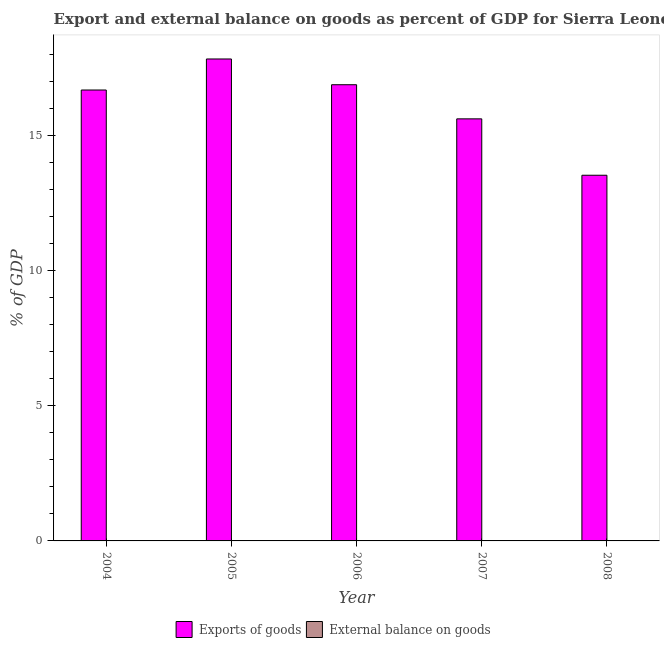How many different coloured bars are there?
Your response must be concise. 1. How many bars are there on the 5th tick from the left?
Make the answer very short. 1. How many bars are there on the 5th tick from the right?
Offer a very short reply. 1. What is the label of the 4th group of bars from the left?
Keep it short and to the point. 2007. Across all years, what is the maximum export of goods as percentage of gdp?
Your answer should be compact. 17.82. Across all years, what is the minimum export of goods as percentage of gdp?
Make the answer very short. 13.52. In which year was the export of goods as percentage of gdp maximum?
Make the answer very short. 2005. What is the total external balance on goods as percentage of gdp in the graph?
Your answer should be very brief. 0. What is the difference between the export of goods as percentage of gdp in 2005 and that in 2008?
Provide a short and direct response. 4.3. What is the average export of goods as percentage of gdp per year?
Offer a very short reply. 16.1. What is the ratio of the export of goods as percentage of gdp in 2004 to that in 2008?
Ensure brevity in your answer.  1.23. Is the difference between the export of goods as percentage of gdp in 2004 and 2008 greater than the difference between the external balance on goods as percentage of gdp in 2004 and 2008?
Your answer should be very brief. No. What is the difference between the highest and the second highest export of goods as percentage of gdp?
Your answer should be very brief. 0.95. What is the difference between the highest and the lowest export of goods as percentage of gdp?
Offer a very short reply. 4.3. Is the sum of the export of goods as percentage of gdp in 2004 and 2008 greater than the maximum external balance on goods as percentage of gdp across all years?
Give a very brief answer. Yes. How many years are there in the graph?
Your answer should be compact. 5. What is the difference between two consecutive major ticks on the Y-axis?
Give a very brief answer. 5. Are the values on the major ticks of Y-axis written in scientific E-notation?
Provide a short and direct response. No. Where does the legend appear in the graph?
Ensure brevity in your answer.  Bottom center. How many legend labels are there?
Keep it short and to the point. 2. How are the legend labels stacked?
Your answer should be compact. Horizontal. What is the title of the graph?
Your answer should be compact. Export and external balance on goods as percent of GDP for Sierra Leone. What is the label or title of the Y-axis?
Provide a succinct answer. % of GDP. What is the % of GDP in Exports of goods in 2004?
Offer a terse response. 16.67. What is the % of GDP of Exports of goods in 2005?
Ensure brevity in your answer.  17.82. What is the % of GDP in External balance on goods in 2005?
Provide a short and direct response. 0. What is the % of GDP in Exports of goods in 2006?
Offer a terse response. 16.87. What is the % of GDP in External balance on goods in 2006?
Make the answer very short. 0. What is the % of GDP of Exports of goods in 2007?
Provide a succinct answer. 15.6. What is the % of GDP in Exports of goods in 2008?
Offer a terse response. 13.52. Across all years, what is the maximum % of GDP of Exports of goods?
Offer a very short reply. 17.82. Across all years, what is the minimum % of GDP of Exports of goods?
Your response must be concise. 13.52. What is the total % of GDP in Exports of goods in the graph?
Offer a terse response. 80.48. What is the difference between the % of GDP of Exports of goods in 2004 and that in 2005?
Give a very brief answer. -1.15. What is the difference between the % of GDP in Exports of goods in 2004 and that in 2006?
Provide a short and direct response. -0.2. What is the difference between the % of GDP in Exports of goods in 2004 and that in 2007?
Offer a terse response. 1.07. What is the difference between the % of GDP in Exports of goods in 2004 and that in 2008?
Make the answer very short. 3.15. What is the difference between the % of GDP in Exports of goods in 2005 and that in 2006?
Offer a very short reply. 0.95. What is the difference between the % of GDP in Exports of goods in 2005 and that in 2007?
Keep it short and to the point. 2.21. What is the difference between the % of GDP of Exports of goods in 2005 and that in 2008?
Give a very brief answer. 4.3. What is the difference between the % of GDP of Exports of goods in 2006 and that in 2007?
Your answer should be compact. 1.26. What is the difference between the % of GDP in Exports of goods in 2006 and that in 2008?
Offer a terse response. 3.35. What is the difference between the % of GDP of Exports of goods in 2007 and that in 2008?
Your answer should be compact. 2.08. What is the average % of GDP in Exports of goods per year?
Ensure brevity in your answer.  16.1. What is the average % of GDP in External balance on goods per year?
Offer a terse response. 0. What is the ratio of the % of GDP in Exports of goods in 2004 to that in 2005?
Offer a very short reply. 0.94. What is the ratio of the % of GDP of Exports of goods in 2004 to that in 2006?
Your answer should be compact. 0.99. What is the ratio of the % of GDP in Exports of goods in 2004 to that in 2007?
Give a very brief answer. 1.07. What is the ratio of the % of GDP of Exports of goods in 2004 to that in 2008?
Provide a succinct answer. 1.23. What is the ratio of the % of GDP of Exports of goods in 2005 to that in 2006?
Your response must be concise. 1.06. What is the ratio of the % of GDP in Exports of goods in 2005 to that in 2007?
Your answer should be compact. 1.14. What is the ratio of the % of GDP of Exports of goods in 2005 to that in 2008?
Your answer should be compact. 1.32. What is the ratio of the % of GDP in Exports of goods in 2006 to that in 2007?
Offer a terse response. 1.08. What is the ratio of the % of GDP in Exports of goods in 2006 to that in 2008?
Provide a succinct answer. 1.25. What is the ratio of the % of GDP in Exports of goods in 2007 to that in 2008?
Give a very brief answer. 1.15. What is the difference between the highest and the second highest % of GDP in Exports of goods?
Keep it short and to the point. 0.95. What is the difference between the highest and the lowest % of GDP of Exports of goods?
Ensure brevity in your answer.  4.3. 